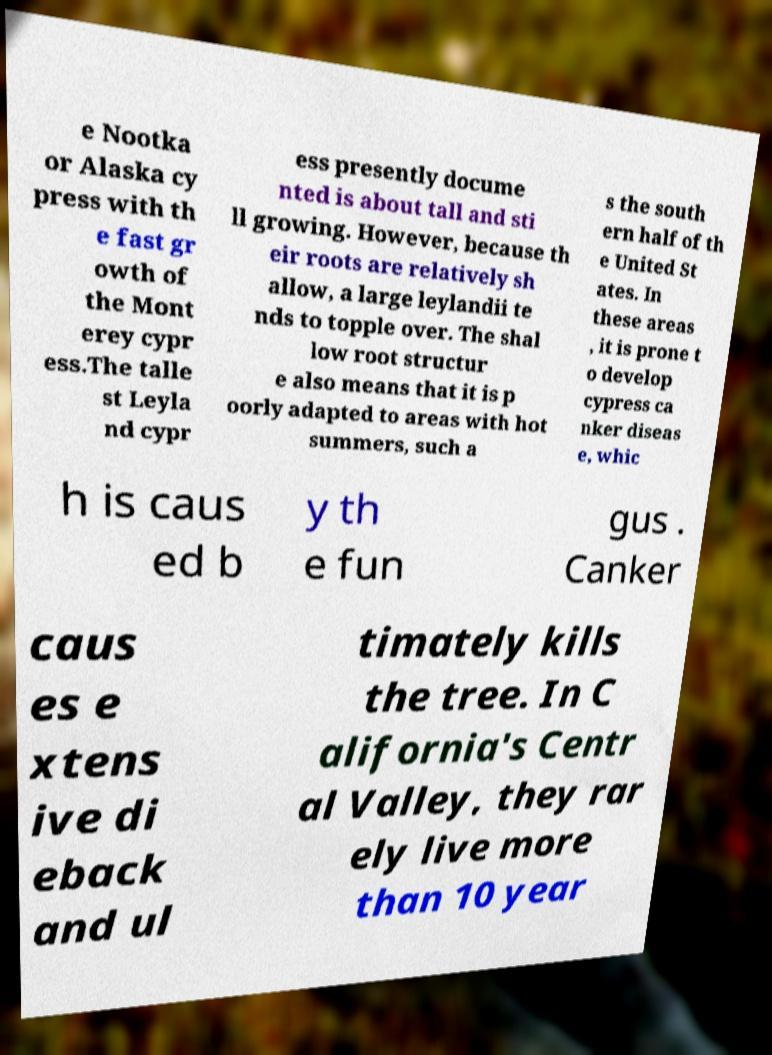Please identify and transcribe the text found in this image. e Nootka or Alaska cy press with th e fast gr owth of the Mont erey cypr ess.The talle st Leyla nd cypr ess presently docume nted is about tall and sti ll growing. However, because th eir roots are relatively sh allow, a large leylandii te nds to topple over. The shal low root structur e also means that it is p oorly adapted to areas with hot summers, such a s the south ern half of th e United St ates. In these areas , it is prone t o develop cypress ca nker diseas e, whic h is caus ed b y th e fun gus . Canker caus es e xtens ive di eback and ul timately kills the tree. In C alifornia's Centr al Valley, they rar ely live more than 10 year 